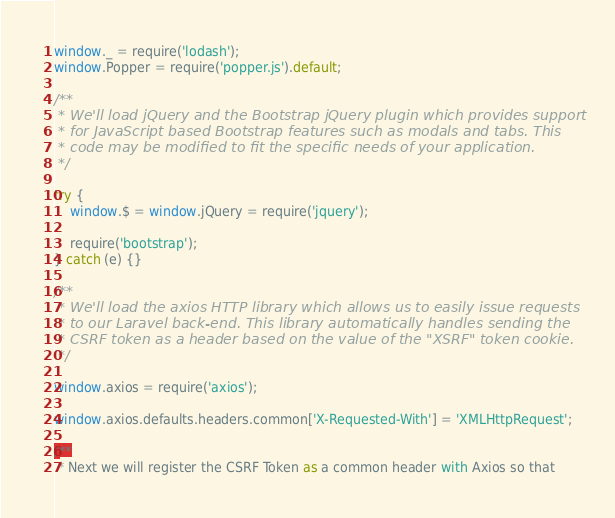<code> <loc_0><loc_0><loc_500><loc_500><_JavaScript_>
window._ = require('lodash');
window.Popper = require('popper.js').default;

/**
 * We'll load jQuery and the Bootstrap jQuery plugin which provides support
 * for JavaScript based Bootstrap features such as modals and tabs. This
 * code may be modified to fit the specific needs of your application.
 */

try {
    window.$ = window.jQuery = require('jquery');

    require('bootstrap');
} catch (e) {}

/**
 * We'll load the axios HTTP library which allows us to easily issue requests
 * to our Laravel back-end. This library automatically handles sending the
 * CSRF token as a header based on the value of the "XSRF" token cookie.
 */

window.axios = require('axios');

window.axios.defaults.headers.common['X-Requested-With'] = 'XMLHttpRequest';

/**
 * Next we will register the CSRF Token as a common header with Axios so that</code> 